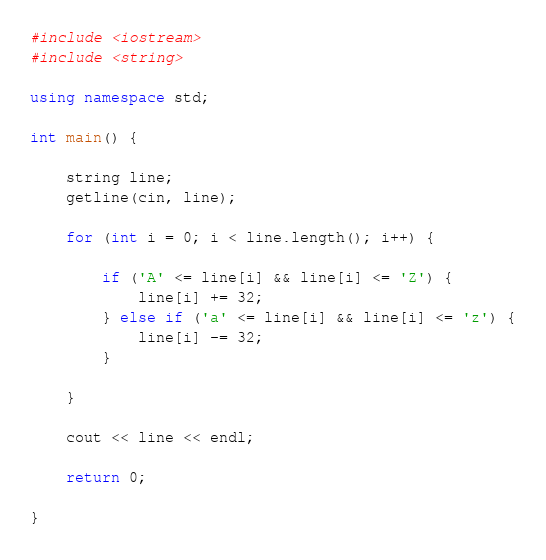<code> <loc_0><loc_0><loc_500><loc_500><_C++_>#include <iostream>
#include <string>

using namespace std;

int main() {

    string line;
    getline(cin, line);

    for (int i = 0; i < line.length(); i++) {

        if ('A' <= line[i] && line[i] <= 'Z') {
            line[i] += 32;
        } else if ('a' <= line[i] && line[i] <= 'z') {
            line[i] -= 32;
        }

    }

    cout << line << endl;

    return 0;

}
</code> 